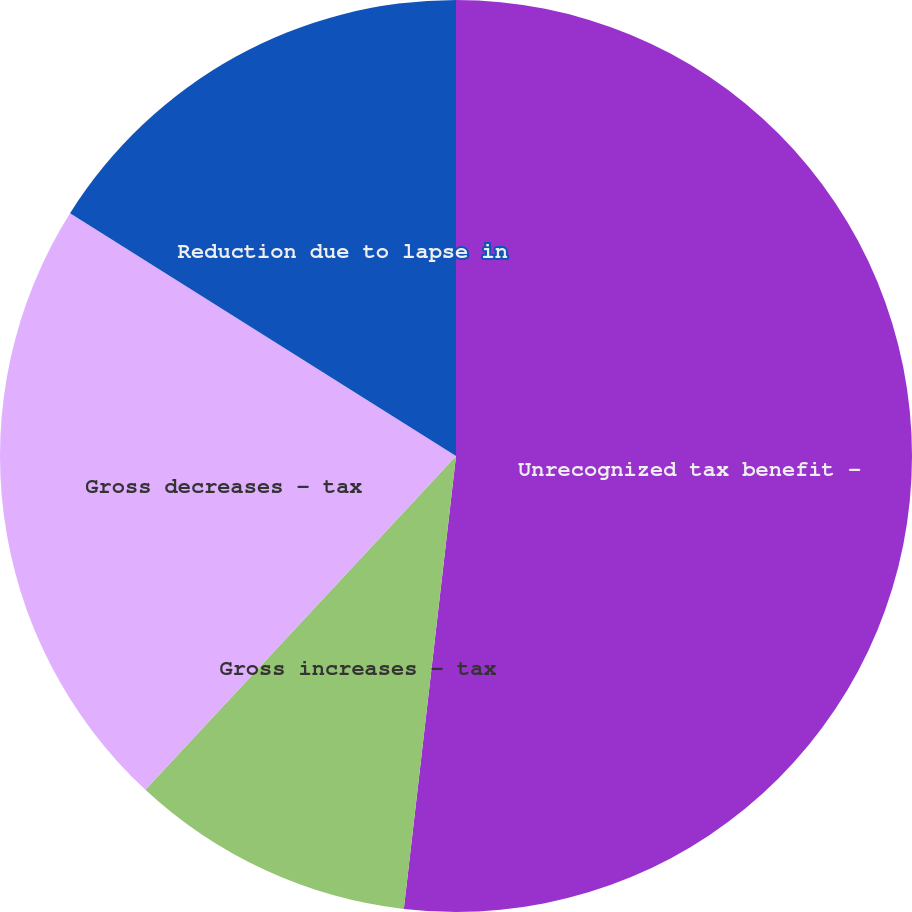Convert chart to OTSL. <chart><loc_0><loc_0><loc_500><loc_500><pie_chart><fcel>Unrecognized tax benefit -<fcel>Gross increases - tax<fcel>Gross decreases - tax<fcel>Reduction due to lapse in<nl><fcel>51.82%<fcel>10.1%<fcel>22.01%<fcel>16.06%<nl></chart> 